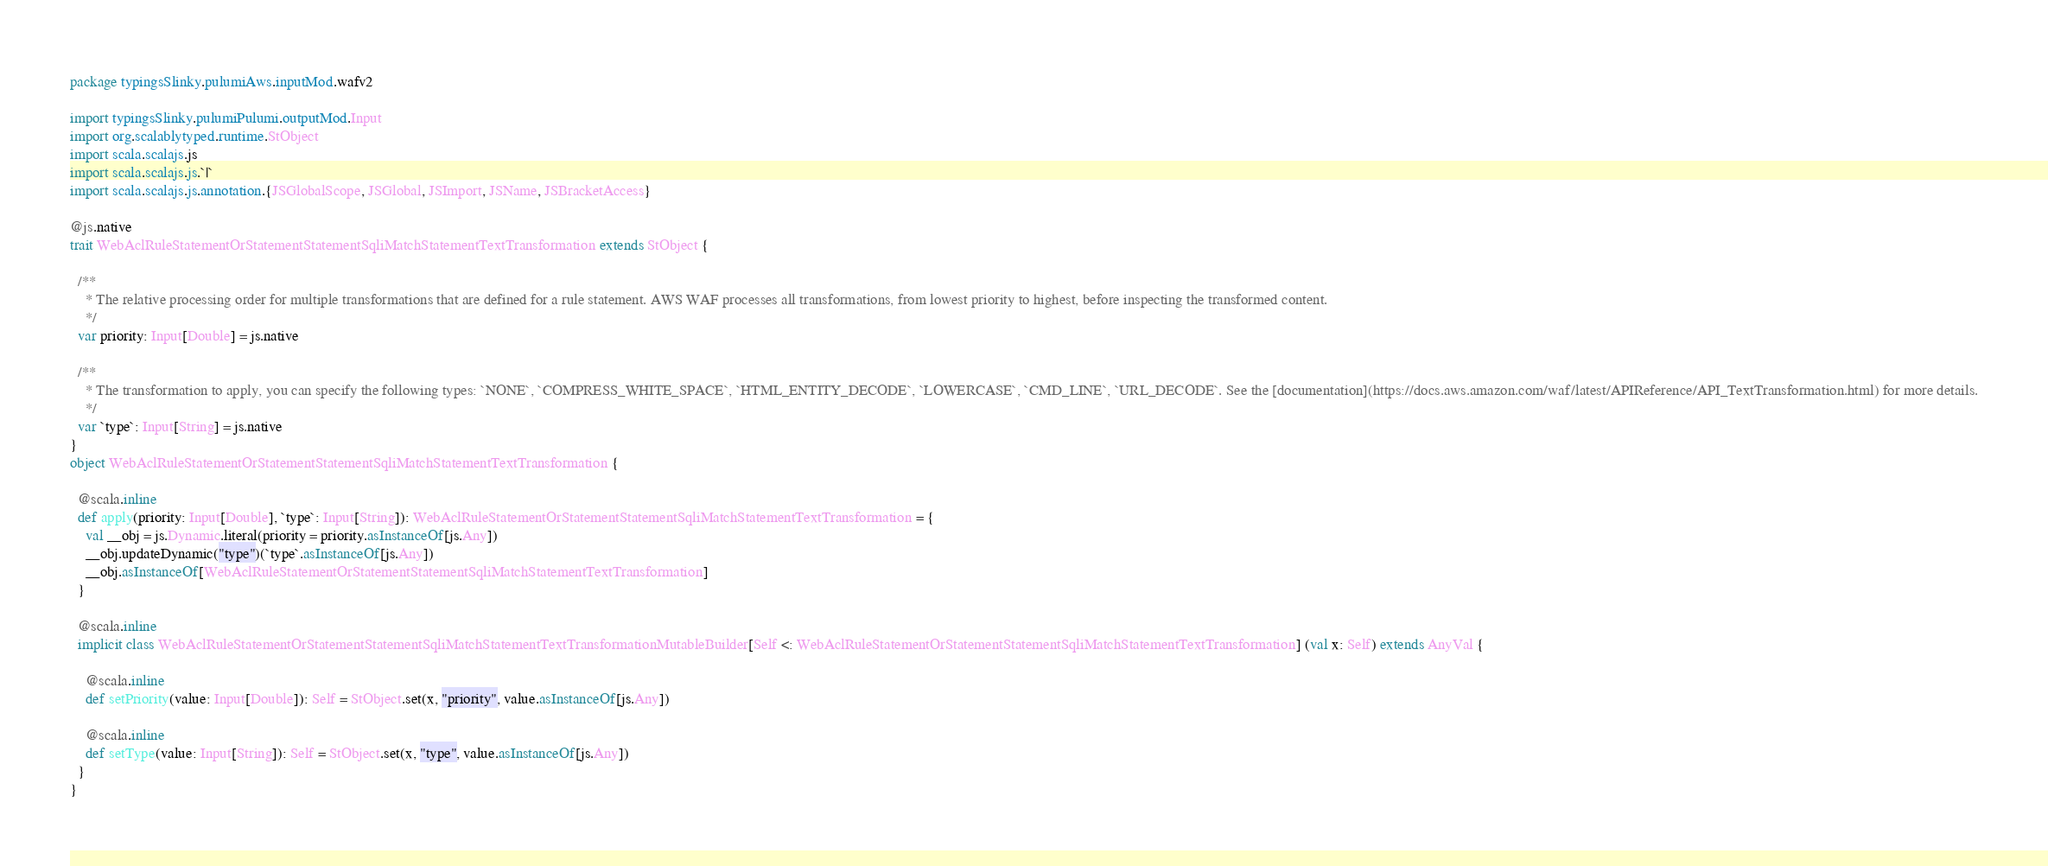Convert code to text. <code><loc_0><loc_0><loc_500><loc_500><_Scala_>package typingsSlinky.pulumiAws.inputMod.wafv2

import typingsSlinky.pulumiPulumi.outputMod.Input
import org.scalablytyped.runtime.StObject
import scala.scalajs.js
import scala.scalajs.js.`|`
import scala.scalajs.js.annotation.{JSGlobalScope, JSGlobal, JSImport, JSName, JSBracketAccess}

@js.native
trait WebAclRuleStatementOrStatementStatementSqliMatchStatementTextTransformation extends StObject {
  
  /**
    * The relative processing order for multiple transformations that are defined for a rule statement. AWS WAF processes all transformations, from lowest priority to highest, before inspecting the transformed content.
    */
  var priority: Input[Double] = js.native
  
  /**
    * The transformation to apply, you can specify the following types: `NONE`, `COMPRESS_WHITE_SPACE`, `HTML_ENTITY_DECODE`, `LOWERCASE`, `CMD_LINE`, `URL_DECODE`. See the [documentation](https://docs.aws.amazon.com/waf/latest/APIReference/API_TextTransformation.html) for more details.
    */
  var `type`: Input[String] = js.native
}
object WebAclRuleStatementOrStatementStatementSqliMatchStatementTextTransformation {
  
  @scala.inline
  def apply(priority: Input[Double], `type`: Input[String]): WebAclRuleStatementOrStatementStatementSqliMatchStatementTextTransformation = {
    val __obj = js.Dynamic.literal(priority = priority.asInstanceOf[js.Any])
    __obj.updateDynamic("type")(`type`.asInstanceOf[js.Any])
    __obj.asInstanceOf[WebAclRuleStatementOrStatementStatementSqliMatchStatementTextTransformation]
  }
  
  @scala.inline
  implicit class WebAclRuleStatementOrStatementStatementSqliMatchStatementTextTransformationMutableBuilder[Self <: WebAclRuleStatementOrStatementStatementSqliMatchStatementTextTransformation] (val x: Self) extends AnyVal {
    
    @scala.inline
    def setPriority(value: Input[Double]): Self = StObject.set(x, "priority", value.asInstanceOf[js.Any])
    
    @scala.inline
    def setType(value: Input[String]): Self = StObject.set(x, "type", value.asInstanceOf[js.Any])
  }
}
</code> 